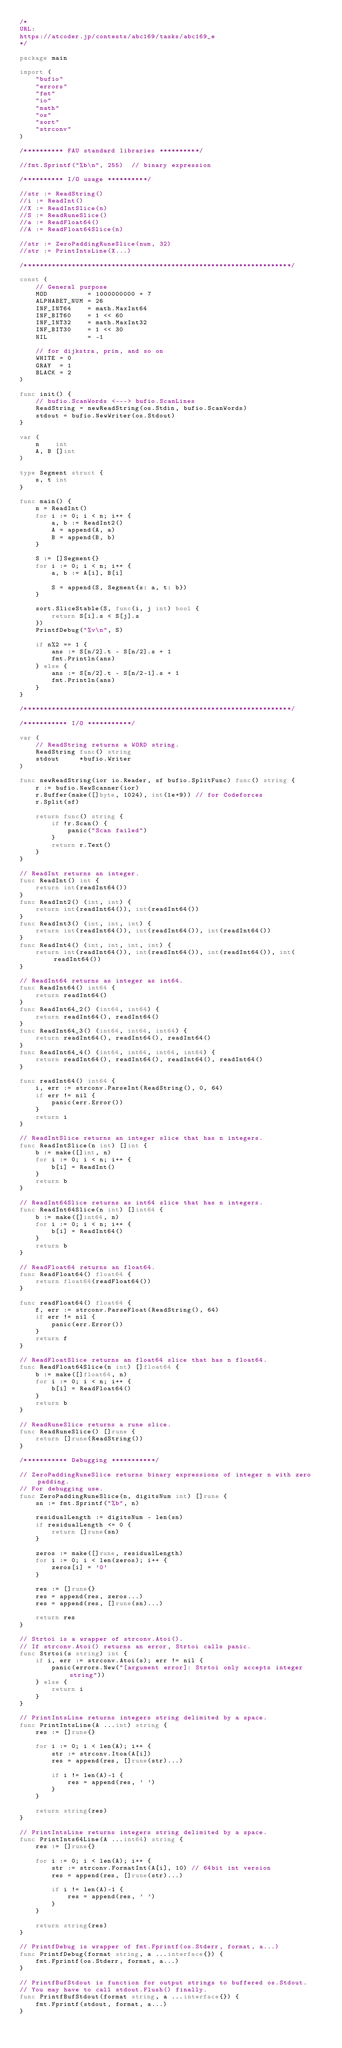<code> <loc_0><loc_0><loc_500><loc_500><_Go_>/*
URL:
https://atcoder.jp/contests/abc169/tasks/abc169_e
*/

package main

import (
	"bufio"
	"errors"
	"fmt"
	"io"
	"math"
	"os"
	"sort"
	"strconv"
)

/********** FAU standard libraries **********/

//fmt.Sprintf("%b\n", 255) 	// binary expression

/********** I/O usage **********/

//str := ReadString()
//i := ReadInt()
//X := ReadIntSlice(n)
//S := ReadRuneSlice()
//a := ReadFloat64()
//A := ReadFloat64Slice(n)

//str := ZeroPaddingRuneSlice(num, 32)
//str := PrintIntsLine(X...)

/*******************************************************************/

const (
	// General purpose
	MOD          = 1000000000 + 7
	ALPHABET_NUM = 26
	INF_INT64    = math.MaxInt64
	INF_BIT60    = 1 << 60
	INF_INT32    = math.MaxInt32
	INF_BIT30    = 1 << 30
	NIL          = -1

	// for dijkstra, prim, and so on
	WHITE = 0
	GRAY  = 1
	BLACK = 2
)

func init() {
	// bufio.ScanWords <---> bufio.ScanLines
	ReadString = newReadString(os.Stdin, bufio.ScanWords)
	stdout = bufio.NewWriter(os.Stdout)
}

var (
	n    int
	A, B []int
)

type Segment struct {
	s, t int
}

func main() {
	n = ReadInt()
	for i := 0; i < n; i++ {
		a, b := ReadInt2()
		A = append(A, a)
		B = append(B, b)
	}

	S := []Segment{}
	for i := 0; i < n; i++ {
		a, b := A[i], B[i]

		S = append(S, Segment{s: a, t: b})
	}

	sort.SliceStable(S, func(i, j int) bool {
		return S[i].s < S[j].s
	})
	PrintfDebug("%v\n", S)

	if n%2 == 1 {
		ans := S[n/2].t - S[n/2].s + 1
		fmt.Println(ans)
	} else {
		ans := S[n/2].t - S[n/2-1].s + 1
		fmt.Println(ans)
	}
}

/*******************************************************************/

/*********** I/O ***********/

var (
	// ReadString returns a WORD string.
	ReadString func() string
	stdout     *bufio.Writer
)

func newReadString(ior io.Reader, sf bufio.SplitFunc) func() string {
	r := bufio.NewScanner(ior)
	r.Buffer(make([]byte, 1024), int(1e+9)) // for Codeforces
	r.Split(sf)

	return func() string {
		if !r.Scan() {
			panic("Scan failed")
		}
		return r.Text()
	}
}

// ReadInt returns an integer.
func ReadInt() int {
	return int(readInt64())
}
func ReadInt2() (int, int) {
	return int(readInt64()), int(readInt64())
}
func ReadInt3() (int, int, int) {
	return int(readInt64()), int(readInt64()), int(readInt64())
}
func ReadInt4() (int, int, int, int) {
	return int(readInt64()), int(readInt64()), int(readInt64()), int(readInt64())
}

// ReadInt64 returns as integer as int64.
func ReadInt64() int64 {
	return readInt64()
}
func ReadInt64_2() (int64, int64) {
	return readInt64(), readInt64()
}
func ReadInt64_3() (int64, int64, int64) {
	return readInt64(), readInt64(), readInt64()
}
func ReadInt64_4() (int64, int64, int64, int64) {
	return readInt64(), readInt64(), readInt64(), readInt64()
}

func readInt64() int64 {
	i, err := strconv.ParseInt(ReadString(), 0, 64)
	if err != nil {
		panic(err.Error())
	}
	return i
}

// ReadIntSlice returns an integer slice that has n integers.
func ReadIntSlice(n int) []int {
	b := make([]int, n)
	for i := 0; i < n; i++ {
		b[i] = ReadInt()
	}
	return b
}

// ReadInt64Slice returns as int64 slice that has n integers.
func ReadInt64Slice(n int) []int64 {
	b := make([]int64, n)
	for i := 0; i < n; i++ {
		b[i] = ReadInt64()
	}
	return b
}

// ReadFloat64 returns an float64.
func ReadFloat64() float64 {
	return float64(readFloat64())
}

func readFloat64() float64 {
	f, err := strconv.ParseFloat(ReadString(), 64)
	if err != nil {
		panic(err.Error())
	}
	return f
}

// ReadFloatSlice returns an float64 slice that has n float64.
func ReadFloat64Slice(n int) []float64 {
	b := make([]float64, n)
	for i := 0; i < n; i++ {
		b[i] = ReadFloat64()
	}
	return b
}

// ReadRuneSlice returns a rune slice.
func ReadRuneSlice() []rune {
	return []rune(ReadString())
}

/*********** Debugging ***********/

// ZeroPaddingRuneSlice returns binary expressions of integer n with zero padding.
// For debugging use.
func ZeroPaddingRuneSlice(n, digitsNum int) []rune {
	sn := fmt.Sprintf("%b", n)

	residualLength := digitsNum - len(sn)
	if residualLength <= 0 {
		return []rune(sn)
	}

	zeros := make([]rune, residualLength)
	for i := 0; i < len(zeros); i++ {
		zeros[i] = '0'
	}

	res := []rune{}
	res = append(res, zeros...)
	res = append(res, []rune(sn)...)

	return res
}

// Strtoi is a wrapper of strconv.Atoi().
// If strconv.Atoi() returns an error, Strtoi calls panic.
func Strtoi(s string) int {
	if i, err := strconv.Atoi(s); err != nil {
		panic(errors.New("[argument error]: Strtoi only accepts integer string"))
	} else {
		return i
	}
}

// PrintIntsLine returns integers string delimited by a space.
func PrintIntsLine(A ...int) string {
	res := []rune{}

	for i := 0; i < len(A); i++ {
		str := strconv.Itoa(A[i])
		res = append(res, []rune(str)...)

		if i != len(A)-1 {
			res = append(res, ' ')
		}
	}

	return string(res)
}

// PrintIntsLine returns integers string delimited by a space.
func PrintInts64Line(A ...int64) string {
	res := []rune{}

	for i := 0; i < len(A); i++ {
		str := strconv.FormatInt(A[i], 10) // 64bit int version
		res = append(res, []rune(str)...)

		if i != len(A)-1 {
			res = append(res, ' ')
		}
	}

	return string(res)
}

// PrintfDebug is wrapper of fmt.Fprintf(os.Stderr, format, a...)
func PrintfDebug(format string, a ...interface{}) {
	fmt.Fprintf(os.Stderr, format, a...)
}

// PrintfBufStdout is function for output strings to buffered os.Stdout.
// You may have to call stdout.Flush() finally.
func PrintfBufStdout(format string, a ...interface{}) {
	fmt.Fprintf(stdout, format, a...)
}
</code> 